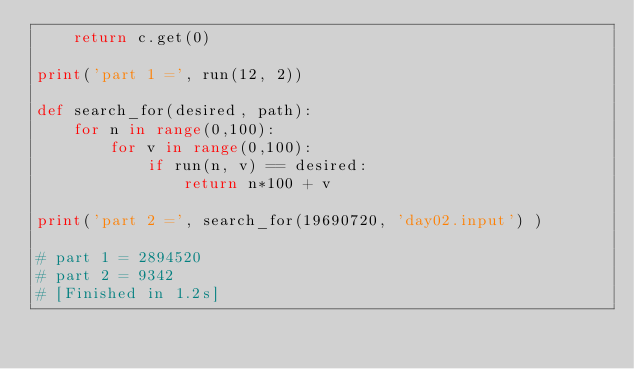<code> <loc_0><loc_0><loc_500><loc_500><_Python_>	return c.get(0)

print('part 1 =', run(12, 2))

def search_for(desired, path):
	for n in range(0,100):
		for v in range(0,100):
			if run(n, v) == desired:
				return n*100 + v

print('part 2 =', search_for(19690720, 'day02.input') )

# part 1 = 2894520
# part 2 = 9342
# [Finished in 1.2s]</code> 